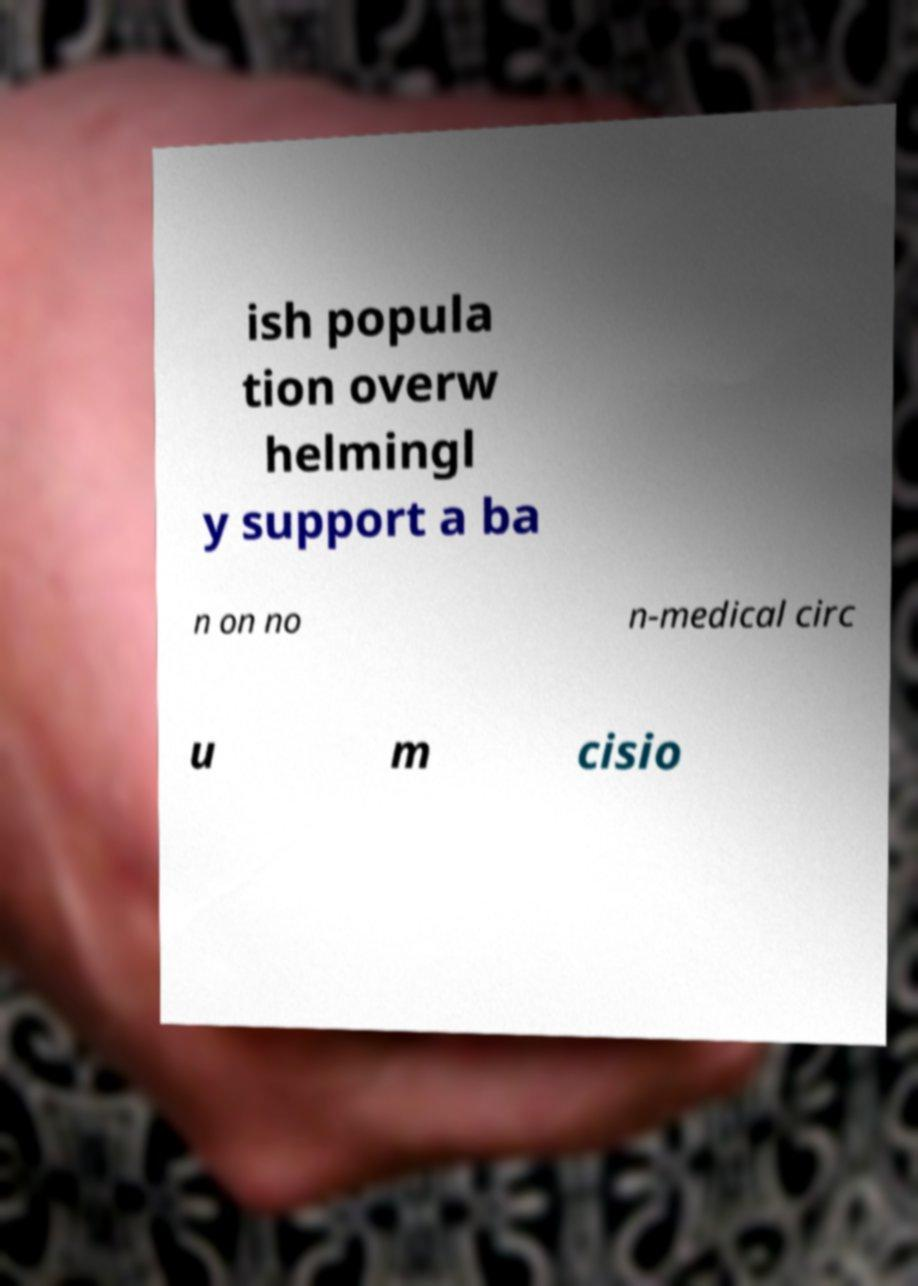Please read and relay the text visible in this image. What does it say? ish popula tion overw helmingl y support a ba n on no n-medical circ u m cisio 